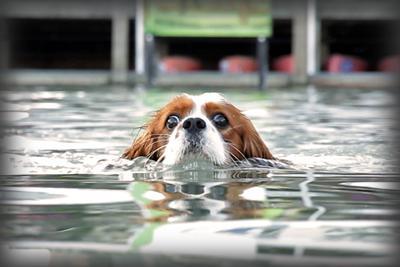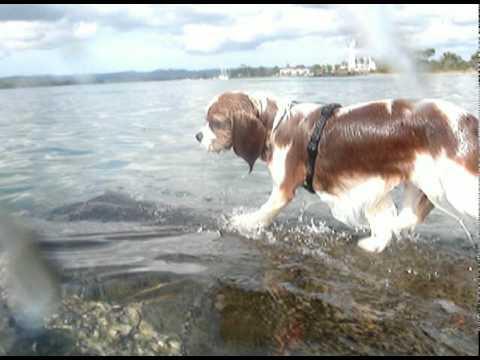The first image is the image on the left, the second image is the image on the right. Evaluate the accuracy of this statement regarding the images: "The righthand image shows a spaniel with a natural body of water, and the lefthand shows a spaniel in pool water.". Is it true? Answer yes or no. Yes. 